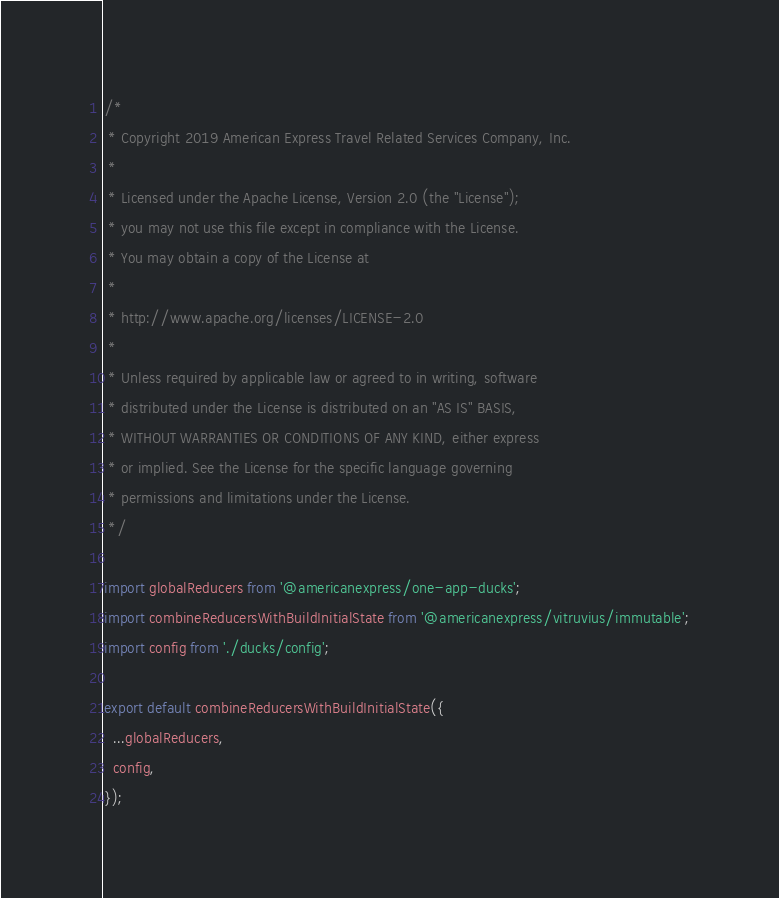<code> <loc_0><loc_0><loc_500><loc_500><_JavaScript_>/*
 * Copyright 2019 American Express Travel Related Services Company, Inc.
 *
 * Licensed under the Apache License, Version 2.0 (the "License");
 * you may not use this file except in compliance with the License.
 * You may obtain a copy of the License at
 *
 * http://www.apache.org/licenses/LICENSE-2.0
 *
 * Unless required by applicable law or agreed to in writing, software
 * distributed under the License is distributed on an "AS IS" BASIS,
 * WITHOUT WARRANTIES OR CONDITIONS OF ANY KIND, either express
 * or implied. See the License for the specific language governing
 * permissions and limitations under the License.
 */

import globalReducers from '@americanexpress/one-app-ducks';
import combineReducersWithBuildInitialState from '@americanexpress/vitruvius/immutable';
import config from './ducks/config';

export default combineReducersWithBuildInitialState({
  ...globalReducers,
  config,
});
</code> 